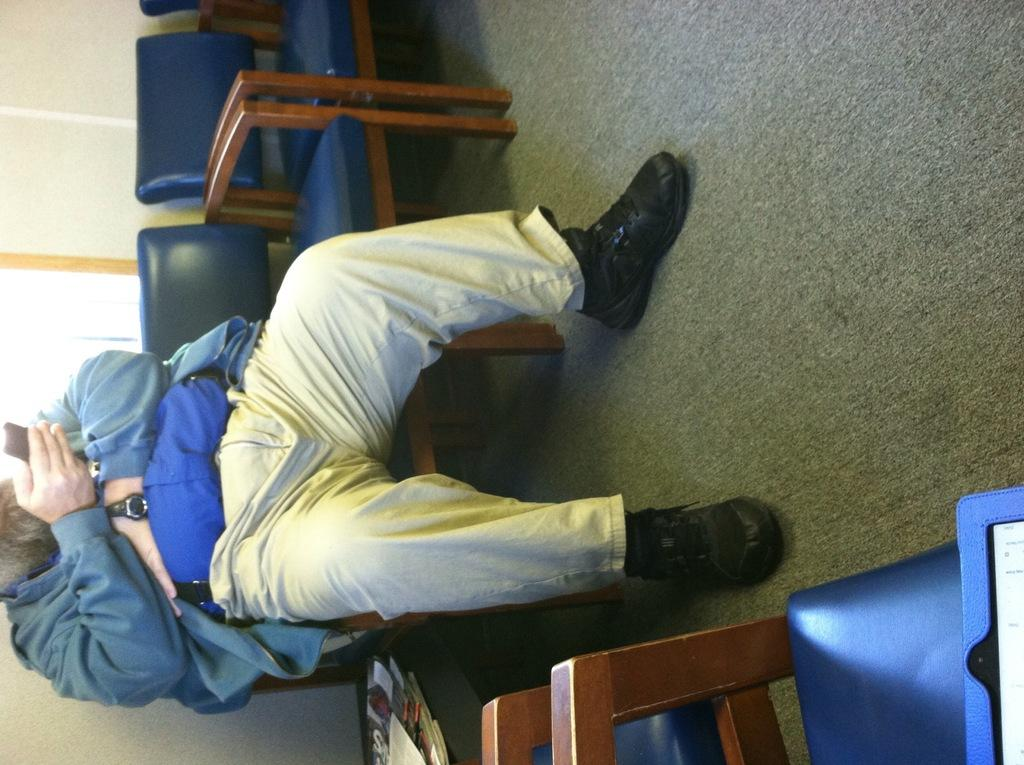What is the main subject of the image? There is a person sitting on a chair in the center of the image. Are there any other chairs visible in the image? Yes, there are additional chairs visible around the person. What is the person holding in the image? The person is holding a phone. Can you see any cobwebs in the image? There is no mention of cobwebs in the provided facts, so it cannot be determined if any are present in the image. 